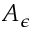Convert formula to latex. <formula><loc_0><loc_0><loc_500><loc_500>A _ { \epsilon }</formula> 